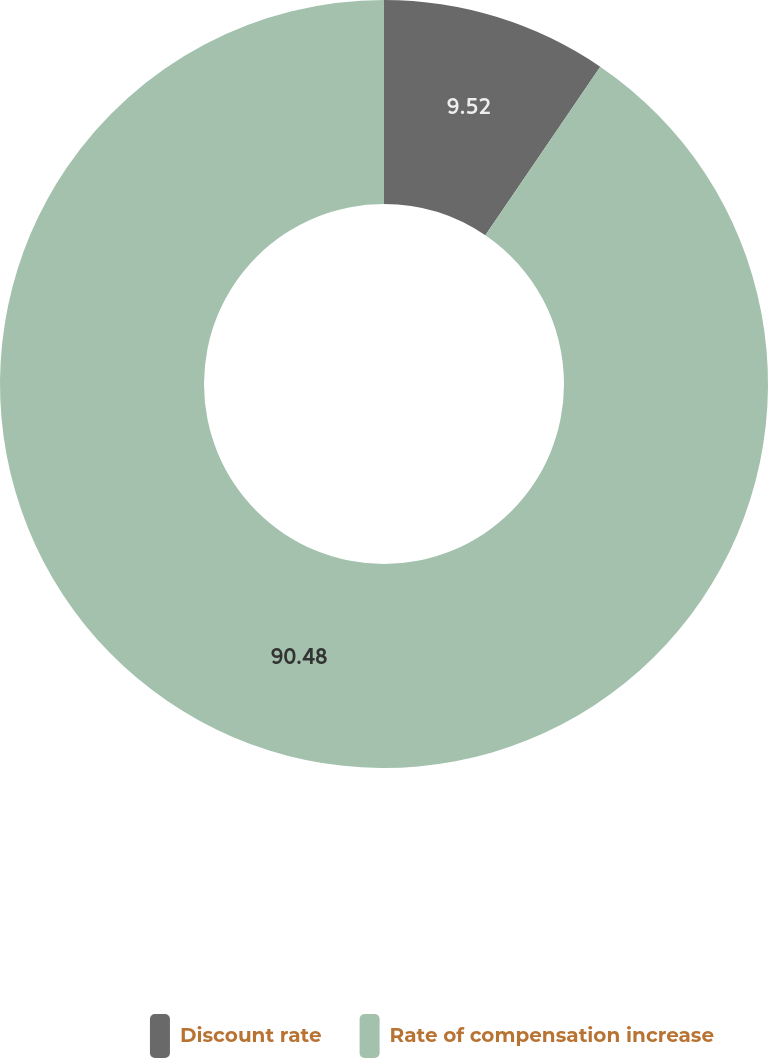Convert chart to OTSL. <chart><loc_0><loc_0><loc_500><loc_500><pie_chart><fcel>Discount rate<fcel>Rate of compensation increase<nl><fcel>9.52%<fcel>90.48%<nl></chart> 